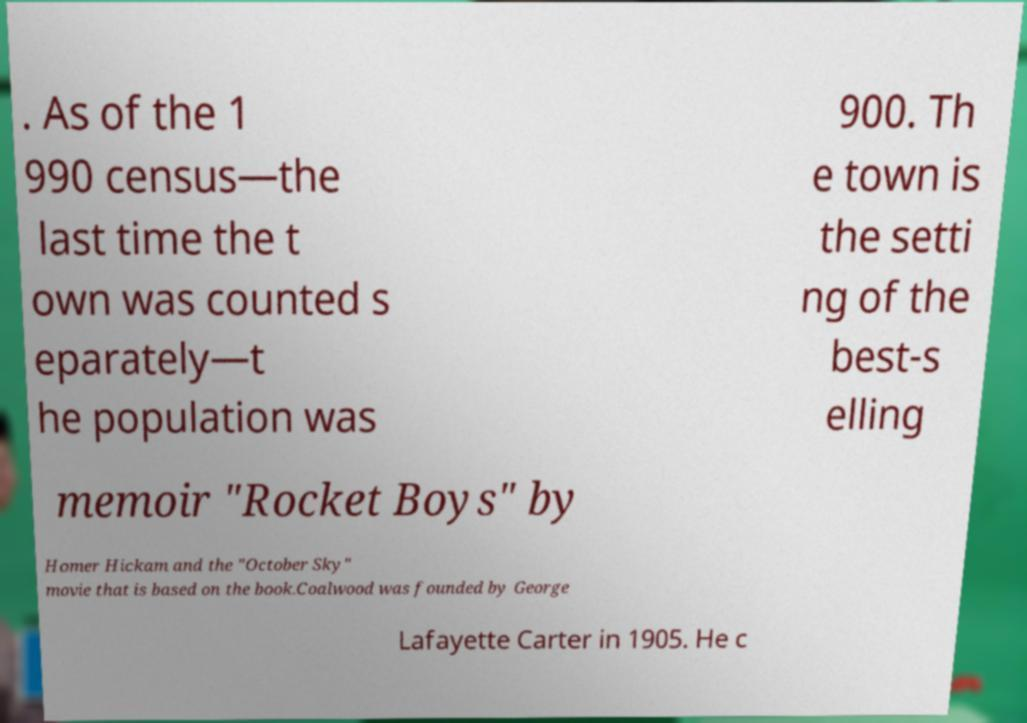Can you accurately transcribe the text from the provided image for me? . As of the 1 990 census—the last time the t own was counted s eparately—t he population was 900. Th e town is the setti ng of the best-s elling memoir "Rocket Boys" by Homer Hickam and the "October Sky" movie that is based on the book.Coalwood was founded by George Lafayette Carter in 1905. He c 